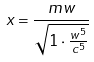Convert formula to latex. <formula><loc_0><loc_0><loc_500><loc_500>x = \frac { m w } { \sqrt { 1 \cdot \frac { w ^ { 5 } } { c ^ { 5 } } } }</formula> 